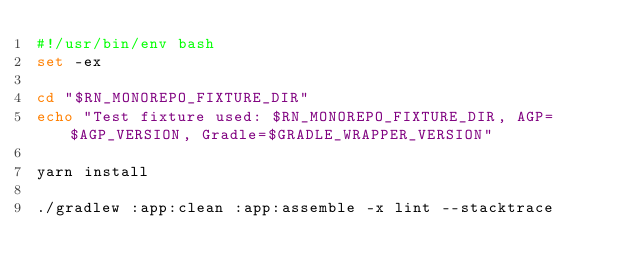Convert code to text. <code><loc_0><loc_0><loc_500><loc_500><_Bash_>#!/usr/bin/env bash
set -ex

cd "$RN_MONOREPO_FIXTURE_DIR"
echo "Test fixture used: $RN_MONOREPO_FIXTURE_DIR, AGP=$AGP_VERSION, Gradle=$GRADLE_WRAPPER_VERSION"

yarn install

./gradlew :app:clean :app:assemble -x lint --stacktrace
</code> 